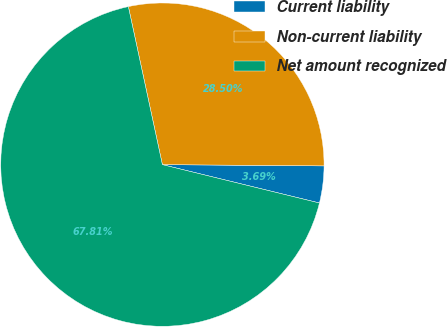Convert chart to OTSL. <chart><loc_0><loc_0><loc_500><loc_500><pie_chart><fcel>Current liability<fcel>Non-current liability<fcel>Net amount recognized<nl><fcel>3.69%<fcel>28.5%<fcel>67.81%<nl></chart> 